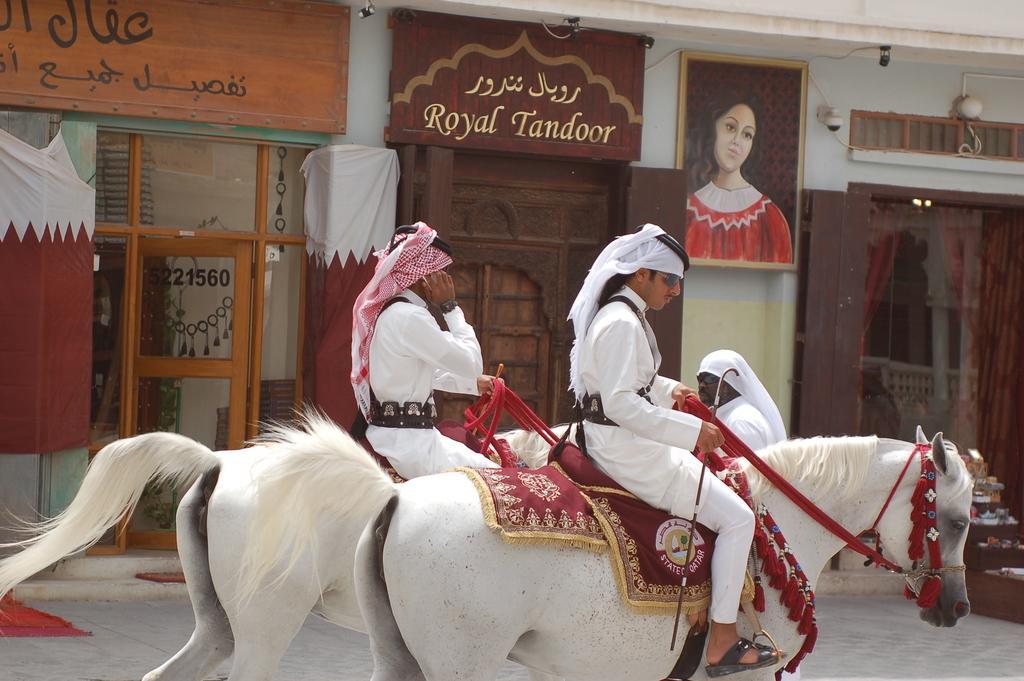How would you summarize this image in a sentence or two? In this image in the foreground there are two horses, and on the horses there are two people sitting and they are holding ropes. And in the background there are doors, wall, photo frames, boards and some clothes and some objects. And at the bottom there is a walkway. 